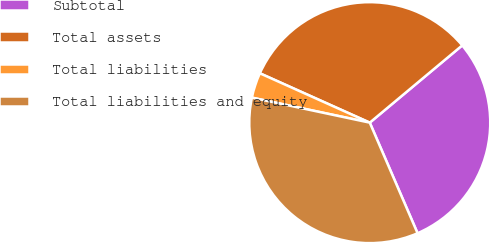<chart> <loc_0><loc_0><loc_500><loc_500><pie_chart><fcel>Subtotal<fcel>Total assets<fcel>Total liabilities<fcel>Total liabilities and equity<nl><fcel>29.58%<fcel>32.2%<fcel>3.39%<fcel>34.82%<nl></chart> 